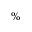Convert formula to latex. <formula><loc_0><loc_0><loc_500><loc_500>\%</formula> 